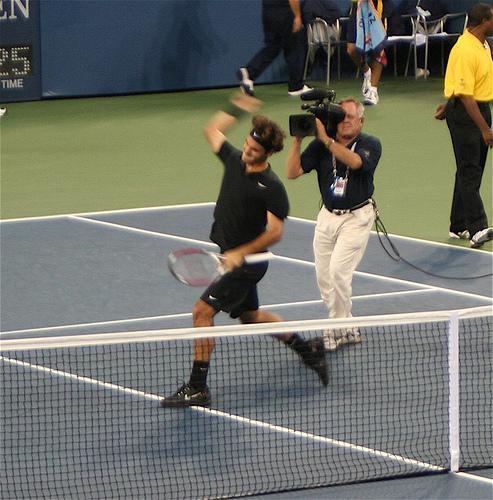How many people are there?
Give a very brief answer. 5. 